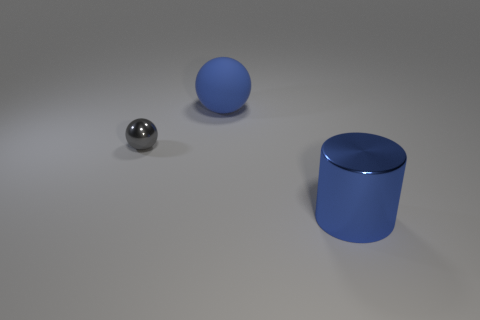Add 1 small brown metallic cylinders. How many objects exist? 4 Subtract all cylinders. How many objects are left? 2 Add 1 cylinders. How many cylinders exist? 2 Subtract 0 purple cylinders. How many objects are left? 3 Subtract all gray shiny objects. Subtract all big cyan balls. How many objects are left? 2 Add 2 small objects. How many small objects are left? 3 